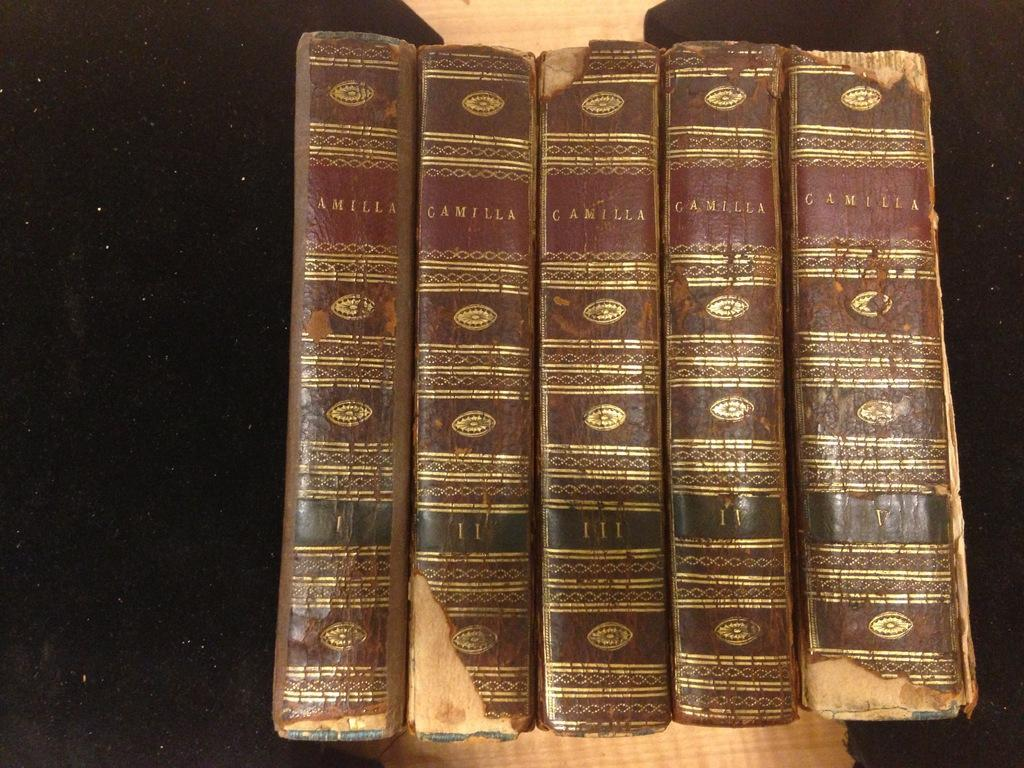<image>
Describe the image concisely. A set of old books by Camilla are lined up showing their spines. 